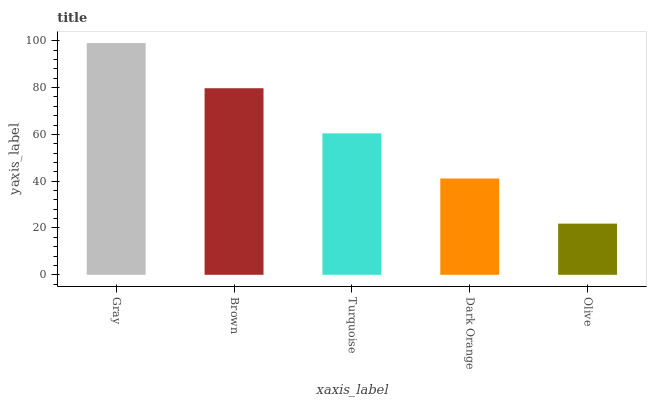Is Olive the minimum?
Answer yes or no. Yes. Is Gray the maximum?
Answer yes or no. Yes. Is Brown the minimum?
Answer yes or no. No. Is Brown the maximum?
Answer yes or no. No. Is Gray greater than Brown?
Answer yes or no. Yes. Is Brown less than Gray?
Answer yes or no. Yes. Is Brown greater than Gray?
Answer yes or no. No. Is Gray less than Brown?
Answer yes or no. No. Is Turquoise the high median?
Answer yes or no. Yes. Is Turquoise the low median?
Answer yes or no. Yes. Is Gray the high median?
Answer yes or no. No. Is Gray the low median?
Answer yes or no. No. 